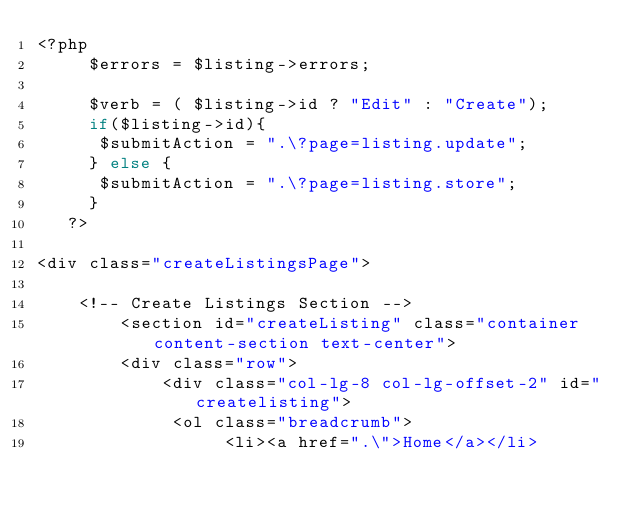Convert code to text. <code><loc_0><loc_0><loc_500><loc_500><_PHP_><?php  
     $errors = $listing->errors; 
     
     $verb = ( $listing->id ? "Edit" : "Create");
     if($listing->id){
      $submitAction = ".\?page=listing.update";
     } else {
      $submitAction = ".\?page=listing.store";
     }
   ?>

<div class="createListingsPage">

    <!-- Create Listings Section -->
        <section id="createListing" class="container content-section text-center">
        <div class="row">
            <div class="col-lg-8 col-lg-offset-2" id="createlisting">
             <ol class="breadcrumb">
                  <li><a href=".\">Home</a></li></code> 